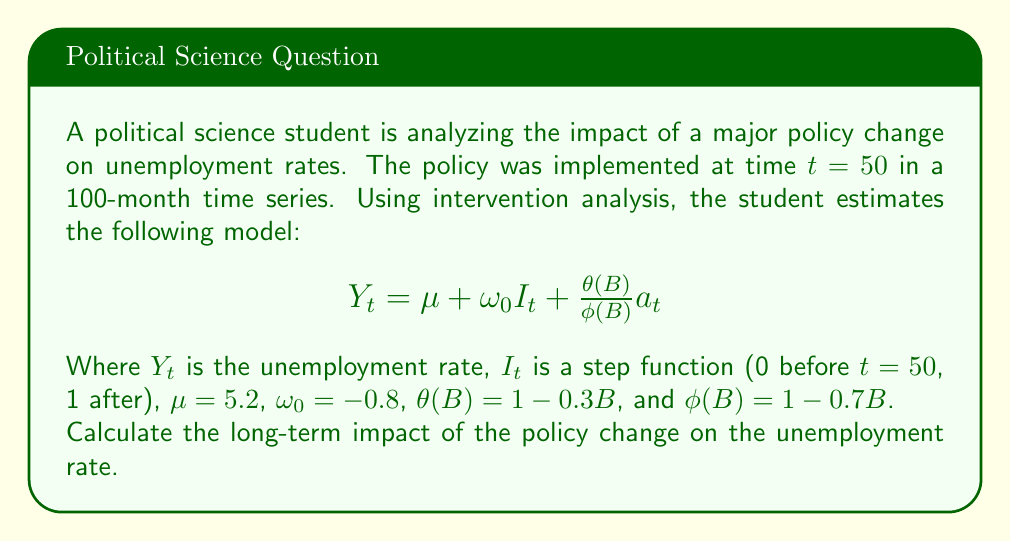Solve this math problem. To solve this problem, we need to understand the components of the intervention analysis model and how to interpret them:

1) The model is: $Y_t = \mu + \omega_0 I_t + \frac{\theta(B)}{\phi(B)} a_t$

2) $\mu = 5.2$ is the baseline unemployment rate before the intervention.

3) $\omega_0 = -0.8$ is the immediate impact of the intervention.

4) $I_t$ is a step function, which is 0 before $t=50$ and 1 after, representing the policy change.

5) $\frac{\theta(B)}{\phi(B)}$ represents the ARMA process of the noise, where:
   $\theta(B) = 1 - 0.3B$ (MA part)
   $\phi(B) = 1 - 0.7B$ (AR part)

To calculate the long-term impact, we need to find the steady-state gain of the transfer function. In this case, it's simply $\omega_0$ because there's no dynamic component in the intervention effect (no denominator in the intervention part).

Therefore, the long-term impact is the same as the immediate impact: -0.8.

This means that in the long run, the unemployment rate is expected to decrease by 0.8 percentage points due to the policy change.

To verify, we can calculate the expected unemployment rate before and after the intervention:

Before: $E[Y_t] = \mu = 5.2$
After (long-term): $E[Y_t] = \mu + \omega_0 = 5.2 + (-0.8) = 4.4$

The difference between these two values confirms the long-term impact of -0.8.
Answer: The long-term impact of the policy change on the unemployment rate is a decrease of 0.8 percentage points. 